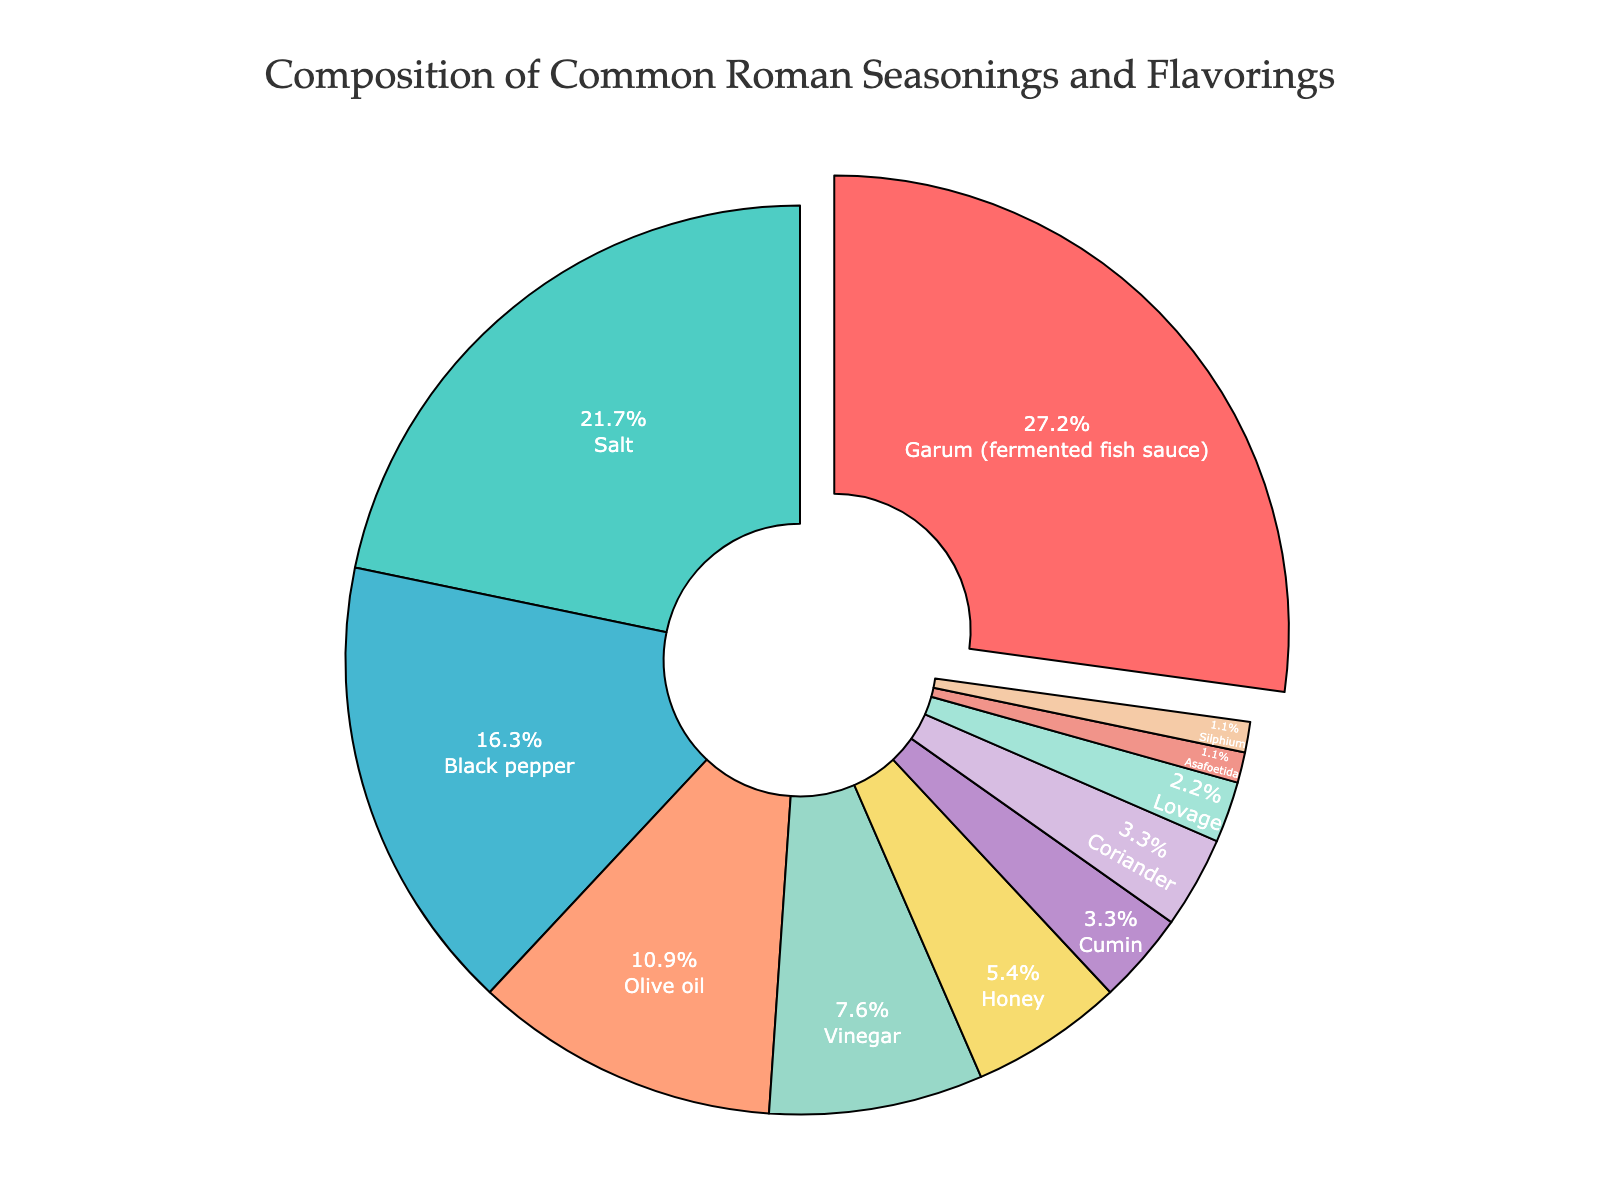Which seasoning or flavoring has the highest percentage? The segment with the largest area represents the seasoning or flavoring with the highest percentage. In this case, it is pulled away from the rest indicating Garum (fermented fish sauce) with 25%.
Answer: Garum (fermented fish sauce) What is the combined percentage of salt and black pepper? First, find the individual percentages for salt (20%) and black pepper (15%). Then, add these two percentages together: 20% + 15% = 35%.
Answer: 35% Which seasonings or flavorings have the smallest percentage, and what are their values? Identify the smallest segments of the pie chart. Asafoetida and Silphium each have the smallest percentages, marked as 1% each.
Answer: Asafoetida and Silphium, 1% each Compare the percentage of olive oil to vinegar. Which one is higher and by how much? Look at the indicated segments for olive oil (10%) and vinegar (7%). Calculate the difference in their percentages: 10% - 7% = 3%. Olive oil is higher by 3%.
Answer: Olive oil is higher by 3% How much more percentage does honey have compared to cumin? Find the represented percentages for honey (5%) and cumin (3%). Subtract the percentage of cumin from honey: 5% - 3% = 2%.
Answer: 2% What is the total percentage of the seasonings and flavorings that are less than 5%? Identify the seasonings and flavorings with less than 5%: Cumin (3%), Coriander (3%), Lovage (2%), Asafoetida (1%), Silphium (1%). Sum these values: 3% + 3% + 2% + 1% + 1% = 10%.
Answer: 10% Which seasoning has a similar percentage to coriander? Identify the percentage of coriander (3%). The segment with a similar percentage is cumin, also at 3%.
Answer: Cumin What is the difference in percentage between the highest and the lowest seasoning? Identify the highest (Garum, 25%) and the lowest seasonings (Asafoetida and Silphium, each 1%). Subtract the lowest from the highest: 25% - 1% = 24%.
Answer: 24% How does the represented area of olive oil compare visually to honey? Visually compare the areas of the segments for olive oil (10%) and honey (5%). Olive oil’s segment is roughly twice as large as honey’s segment.
Answer: Olive oil is roughly twice the area of honey What percentage do the three most common seasonings and flavorings make up together? Identify the three highest percentages: Garum (25%), Salt (20%), Black Pepper (15%). Sum these values: 25% + 20% + 15% = 60%.
Answer: 60% 